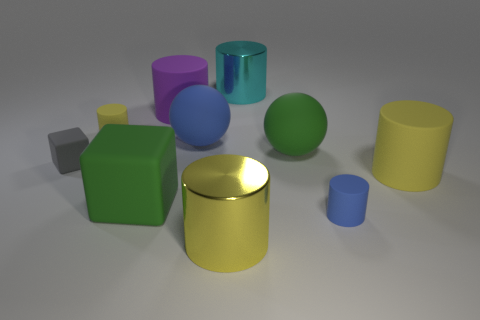How would you describe the lighting and its effect on the colors of the objects? The image is illuminated by soft, diffused lighting, which creates gentle shadows and subtle highlights. This type of lighting helps to enhance the true colors of the objects, giving them a matte and realistic appearance without harsh reflections. 